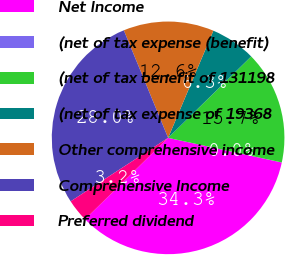<chart> <loc_0><loc_0><loc_500><loc_500><pie_chart><fcel>Net Income<fcel>(net of tax expense (benefit)<fcel>(net of tax benefit of 131198<fcel>(net of tax expense of 19368<fcel>Other comprehensive income<fcel>Comprehensive Income<fcel>Preferred dividend<nl><fcel>34.26%<fcel>0.01%<fcel>15.73%<fcel>6.3%<fcel>12.58%<fcel>27.97%<fcel>3.15%<nl></chart> 